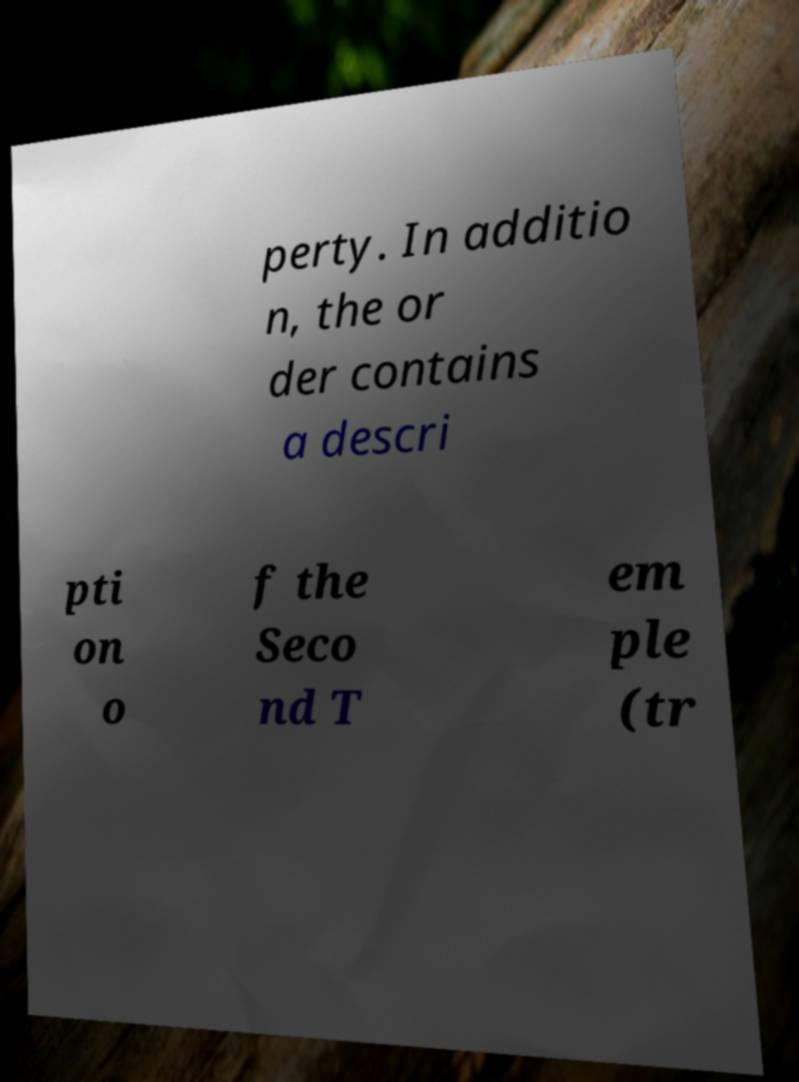For documentation purposes, I need the text within this image transcribed. Could you provide that? perty. In additio n, the or der contains a descri pti on o f the Seco nd T em ple (tr 